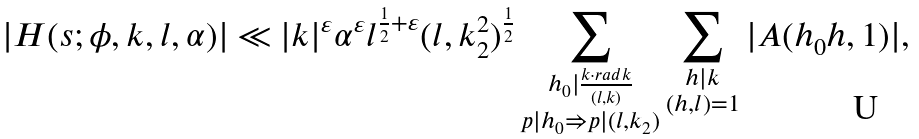<formula> <loc_0><loc_0><loc_500><loc_500>| H ( s ; \phi , k , l , \alpha ) | \ll | k | ^ { \varepsilon } \alpha ^ { \varepsilon } l ^ { \frac { 1 } { 2 } + \varepsilon } ( l , k _ { 2 } ^ { 2 } ) ^ { \frac { 1 } { 2 } } \sum _ { \substack { h _ { 0 } | \frac { k \cdot r a d k } { ( l , k ) } \\ p | h _ { 0 } \Rightarrow p | ( l , k _ { 2 } ) } } \sum _ { \substack { h | k \\ ( h , l ) = 1 } } | A ( h _ { 0 } h , 1 ) | ,</formula> 